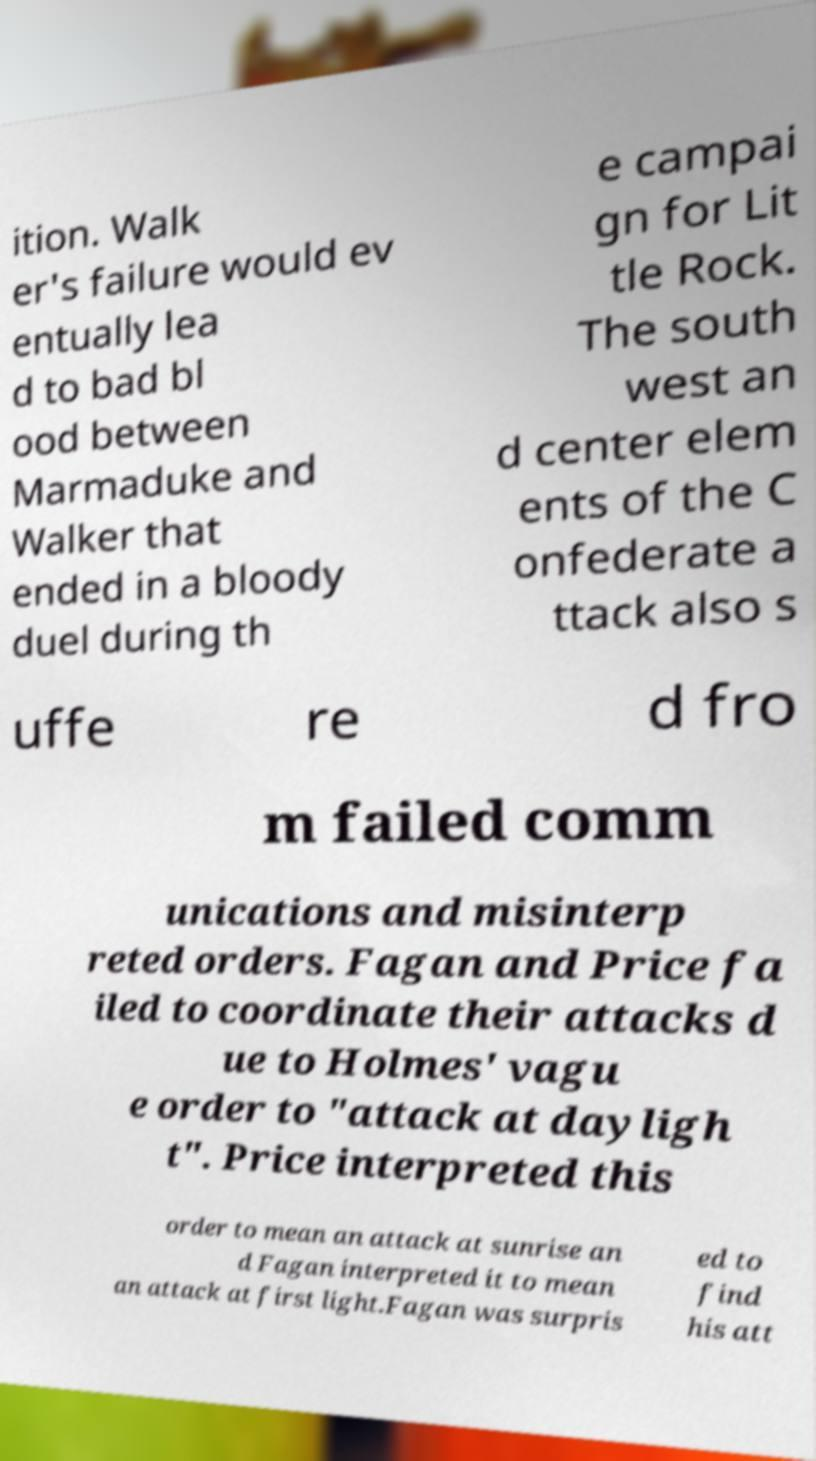For documentation purposes, I need the text within this image transcribed. Could you provide that? ition. Walk er's failure would ev entually lea d to bad bl ood between Marmaduke and Walker that ended in a bloody duel during th e campai gn for Lit tle Rock. The south west an d center elem ents of the C onfederate a ttack also s uffe re d fro m failed comm unications and misinterp reted orders. Fagan and Price fa iled to coordinate their attacks d ue to Holmes' vagu e order to "attack at dayligh t". Price interpreted this order to mean an attack at sunrise an d Fagan interpreted it to mean an attack at first light.Fagan was surpris ed to find his att 